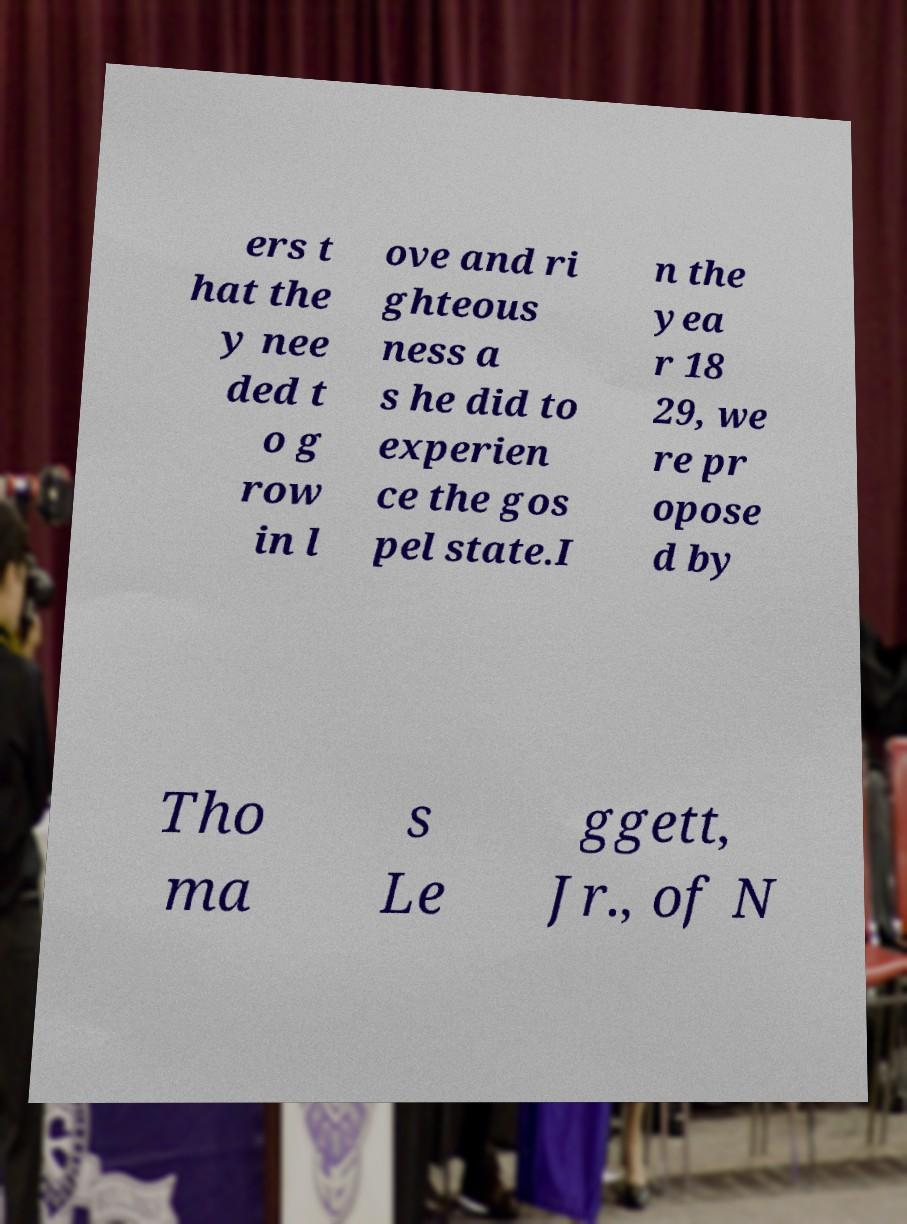Please read and relay the text visible in this image. What does it say? ers t hat the y nee ded t o g row in l ove and ri ghteous ness a s he did to experien ce the gos pel state.I n the yea r 18 29, we re pr opose d by Tho ma s Le ggett, Jr., of N 